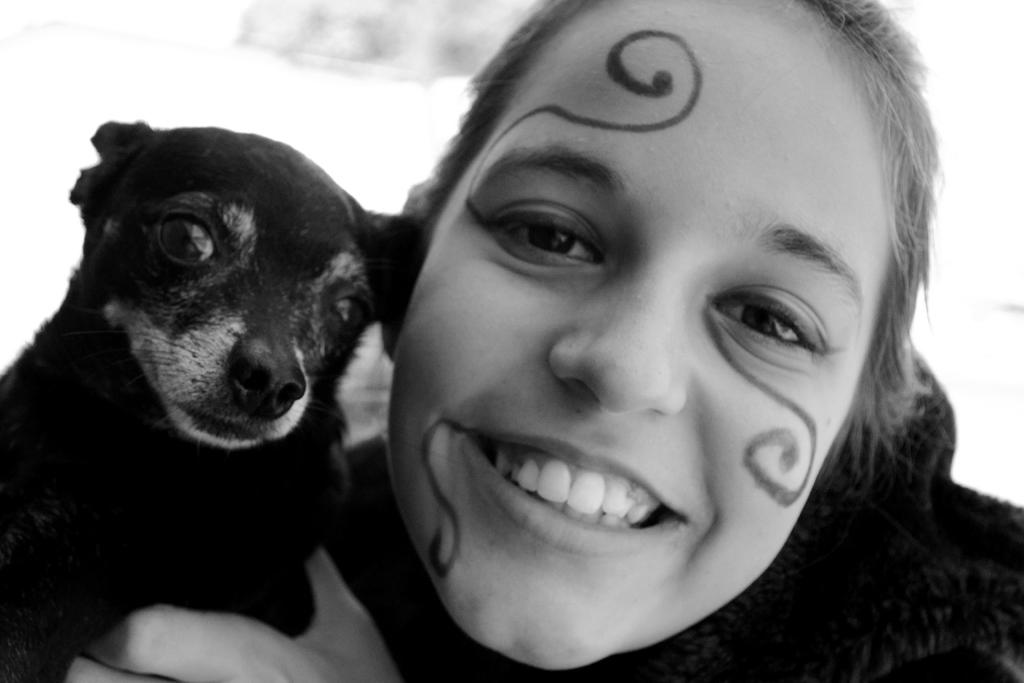Who is present in the image? There is a woman in the image. What is the woman holding in the image? The woman is holding a black color dog. What type of growth can be seen on the dog's eyes in the image? There is no mention of any growth on the dog's eyes in the image, and the dog's eyes are not visible in the provided facts. 